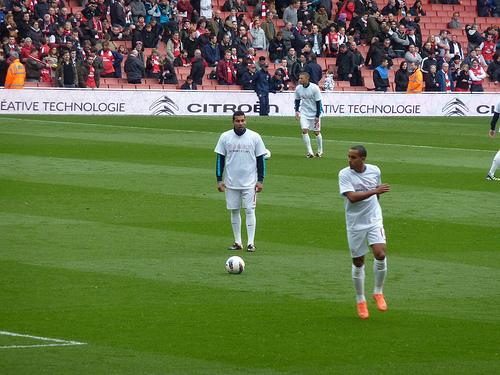What kind of event is being depicted in the image? A daytime soccer match is taking place on a green field with soccer players, a crowd of fans, and numerous advertisements. List the main elements in the scene, including objects and participants. Soccer ball, field, boundary board, chairs, soccer players, crowd, and various soccer-related advertisements are present in the scene. Mention the predominant colors found in the image. The image has a green soccer field, white lines and uniforms, red chairs, a white boundary board, and orange soccer cleats. Mention the primary activity taking place in the image Soccer players are competing on a green field, as fans cheer them on and watch the game in progress. Provide a brief overview of the scene in the image. A soccer match is taking place on a green field with white lines, players in white uniforms, orange cleats, and a white and black ball, as a crowd of fans watches. Narrate the setting of the image in one sentence. The image captures an intense daytime soccer match in a nearly full stadium with players, fans, and surrounding advertisements. Briefly describe the location shown in the image The image shows an outdoor soccer field inside a stadium with green grass, white lines, red seats, and a crowd of spectators. Identify the main objects and their characteristics in the image. A white and black soccer ball, green field with white lines, white boundary board, red chairs, and orange cleats are seen during a daytime match. Describe the clothing and accessories worn by the soccer players. Soccer players are wearing white uniforms with blue stripes on shirt sleeves, white leg sleeves, and orange soccer cleats. Describe the background and atmosphere of the image. A crowd of cheering fans watch a soccer match on a green field during the daytime, surrounded by red chairs, white lines, and advertisements. 